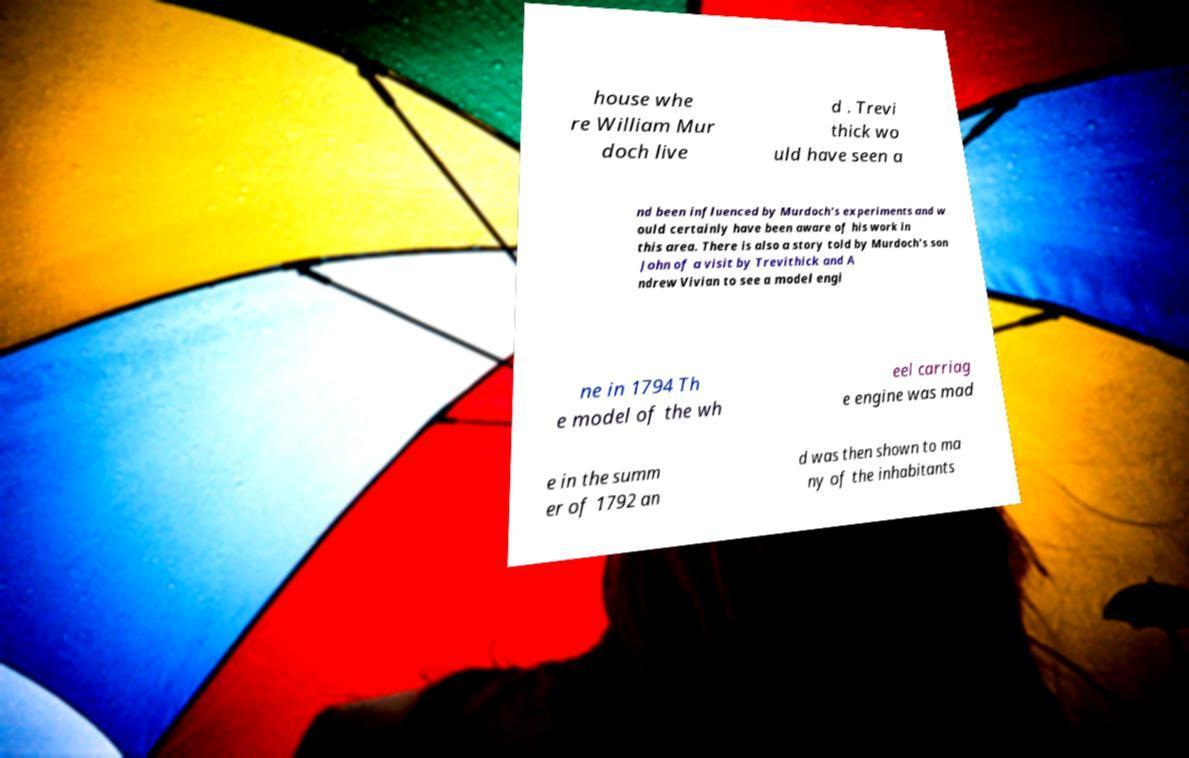Can you read and provide the text displayed in the image?This photo seems to have some interesting text. Can you extract and type it out for me? house whe re William Mur doch live d . Trevi thick wo uld have seen a nd been influenced by Murdoch's experiments and w ould certainly have been aware of his work in this area. There is also a story told by Murdoch's son John of a visit by Trevithick and A ndrew Vivian to see a model engi ne in 1794 Th e model of the wh eel carriag e engine was mad e in the summ er of 1792 an d was then shown to ma ny of the inhabitants 